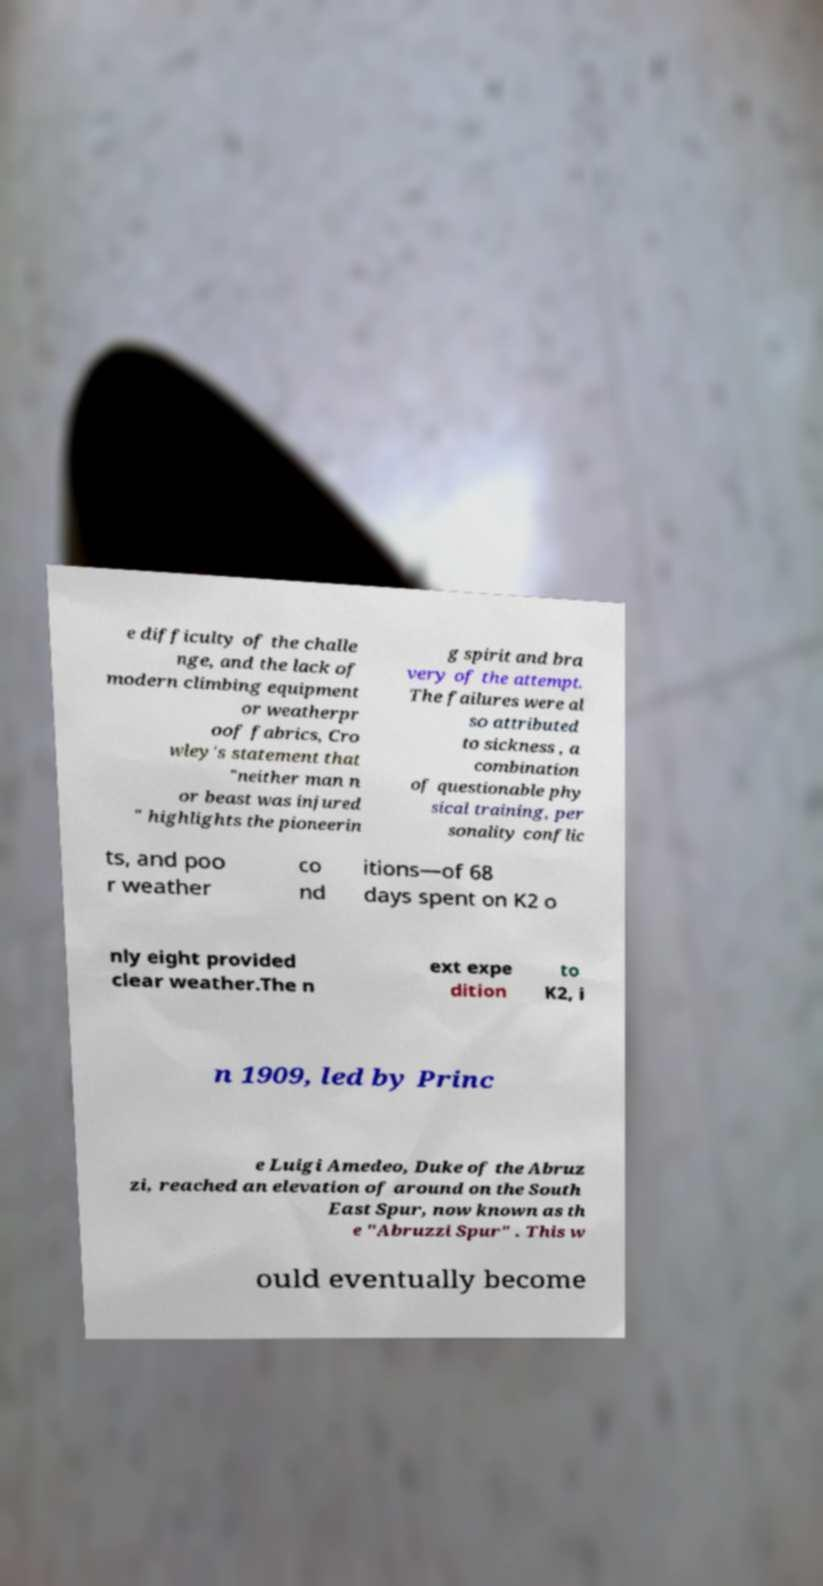Could you assist in decoding the text presented in this image and type it out clearly? e difficulty of the challe nge, and the lack of modern climbing equipment or weatherpr oof fabrics, Cro wley's statement that "neither man n or beast was injured " highlights the pioneerin g spirit and bra very of the attempt. The failures were al so attributed to sickness , a combination of questionable phy sical training, per sonality conflic ts, and poo r weather co nd itions—of 68 days spent on K2 o nly eight provided clear weather.The n ext expe dition to K2, i n 1909, led by Princ e Luigi Amedeo, Duke of the Abruz zi, reached an elevation of around on the South East Spur, now known as th e "Abruzzi Spur" . This w ould eventually become 